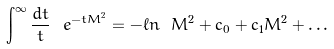Convert formula to latex. <formula><loc_0><loc_0><loc_500><loc_500>\int ^ { \infty } { \frac { d t } { t } } \ e ^ { - t M ^ { 2 } } = - \ell n \ M ^ { 2 } + c _ { 0 } + c _ { 1 } M ^ { 2 } + \dots</formula> 